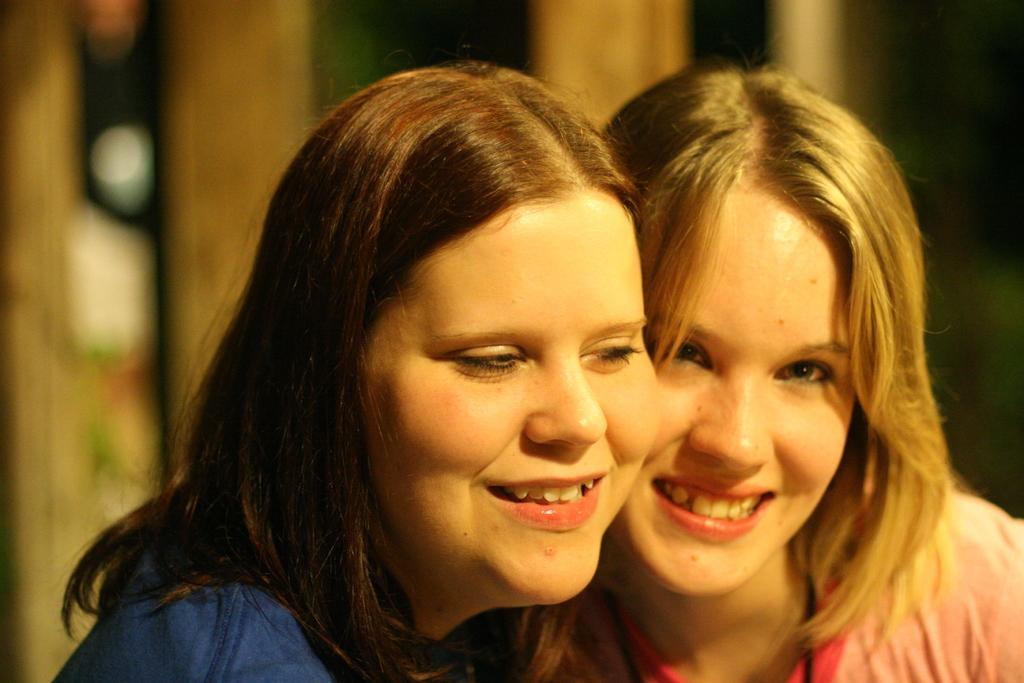How many people are in the image? There are two ladies in the image. What is the facial expression of the ladies? The ladies are smiling. What can be seen in the background of the image? There are lights and a wall visible in the background of the image. What type of produce is being harvested by the ladies in the image? There is no produce or harvesting activity depicted in the image; it features two ladies smiling. What color is the rest of the room in the image? The provided facts do not mention the color of the room or any other part of the image besides the ladies and the background. 